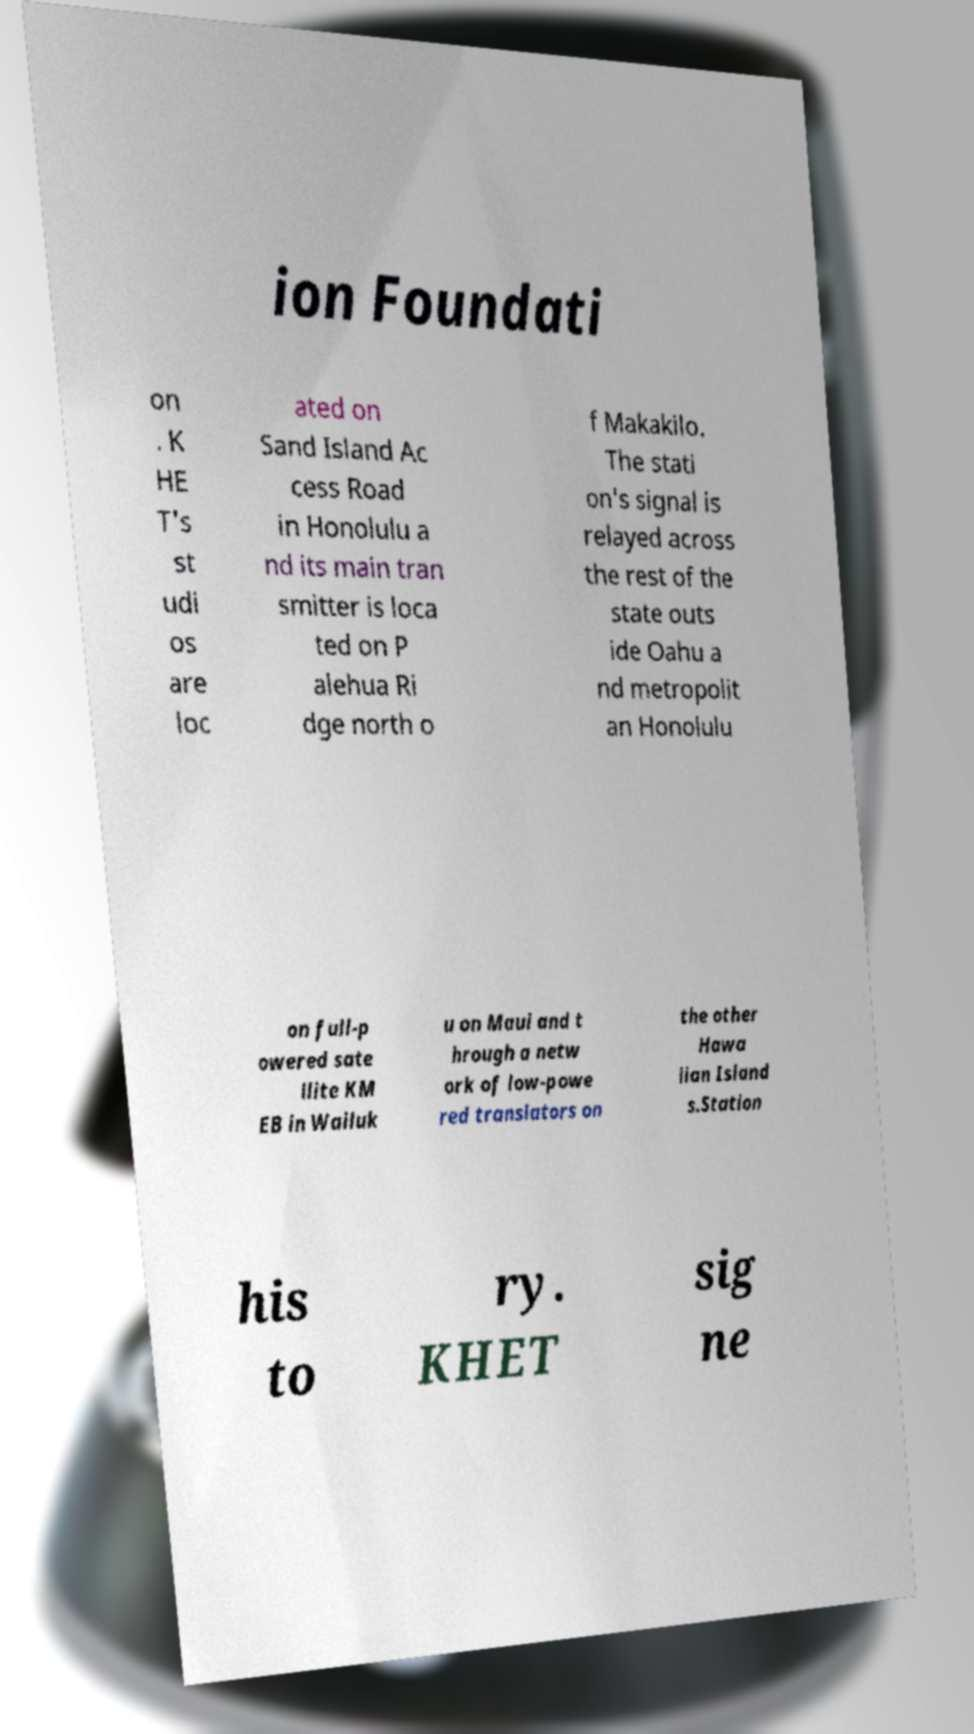I need the written content from this picture converted into text. Can you do that? ion Foundati on . K HE T's st udi os are loc ated on Sand Island Ac cess Road in Honolulu a nd its main tran smitter is loca ted on P alehua Ri dge north o f Makakilo. The stati on's signal is relayed across the rest of the state outs ide Oahu a nd metropolit an Honolulu on full-p owered sate llite KM EB in Wailuk u on Maui and t hrough a netw ork of low-powe red translators on the other Hawa iian Island s.Station his to ry. KHET sig ne 